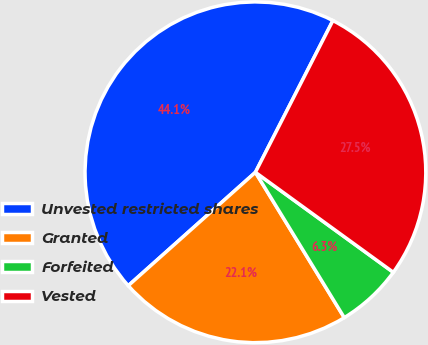Convert chart to OTSL. <chart><loc_0><loc_0><loc_500><loc_500><pie_chart><fcel>Unvested restricted shares<fcel>Granted<fcel>Forfeited<fcel>Vested<nl><fcel>44.1%<fcel>22.14%<fcel>6.28%<fcel>27.47%<nl></chart> 